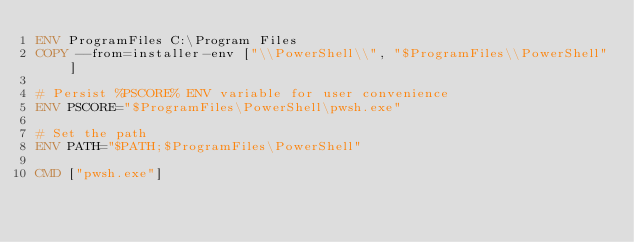<code> <loc_0><loc_0><loc_500><loc_500><_Dockerfile_>ENV ProgramFiles C:\Program Files
COPY --from=installer-env ["\\PowerShell\\", "$ProgramFiles\\PowerShell"]

# Persist %PSCORE% ENV variable for user convenience
ENV PSCORE="$ProgramFiles\PowerShell\pwsh.exe"

# Set the path
ENV PATH="$PATH;$ProgramFiles\PowerShell"

CMD ["pwsh.exe"]
</code> 